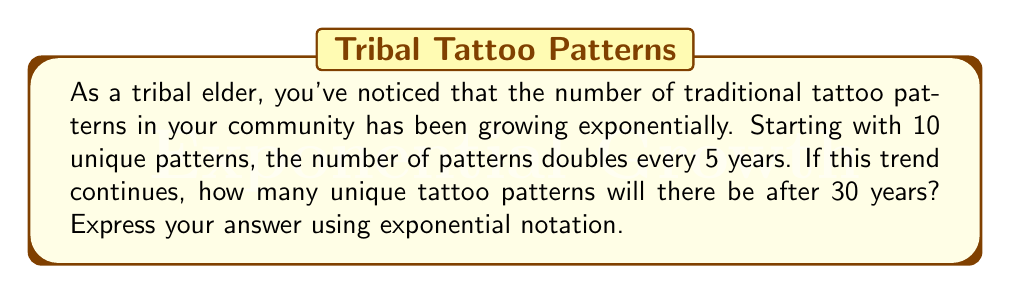Can you answer this question? Let's approach this problem step-by-step using exponential functions:

1) We start with the initial number of patterns: $N_0 = 10$

2) The growth rate is doubling every 5 years. This means that in one 5-year period, the number is multiplied by 2. We can express this as:

   $N = N_0 \cdot 2^t$

   Where $t$ is the number of 5-year periods.

3) We want to know the number of patterns after 30 years. To find how many 5-year periods are in 30 years:

   $\frac{30 \text{ years}}{5 \text{ years per period}} = 6 \text{ periods}$

4) Now we can plug this into our exponential function:

   $N = 10 \cdot 2^6$

5) Calculate $2^6$:
   
   $2^6 = 2 \cdot 2 \cdot 2 \cdot 2 \cdot 2 \cdot 2 = 64$

6) Finally, multiply:

   $N = 10 \cdot 64 = 640$

Therefore, after 30 years, there will be 640 unique tattoo patterns.
Answer: $640$ or $10 \cdot 2^6$ 